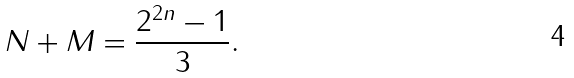Convert formula to latex. <formula><loc_0><loc_0><loc_500><loc_500>N + M = \frac { 2 ^ { 2 n } - 1 } { 3 } .</formula> 